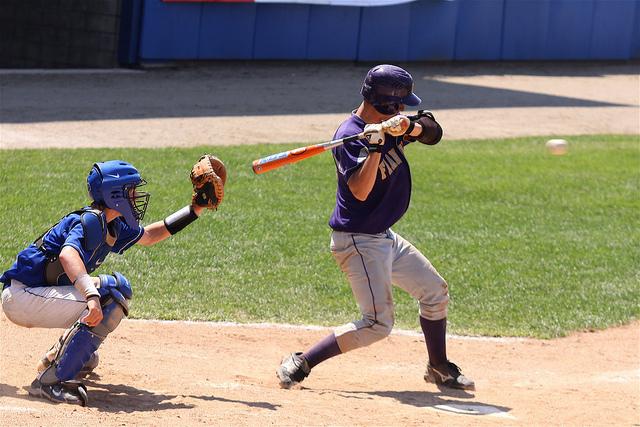Is grass on the field?
Quick response, please. Yes. If the ball gets by the batter, will it be a ball or a strike?
Short answer required. Strike. What color is the wall?
Be succinct. Blue. What color is the batters shirt?
Quick response, please. Blue. Has the batter swung the bat yet?
Give a very brief answer. No. Is the band playing baseball or softball?
Give a very brief answer. Baseball. 